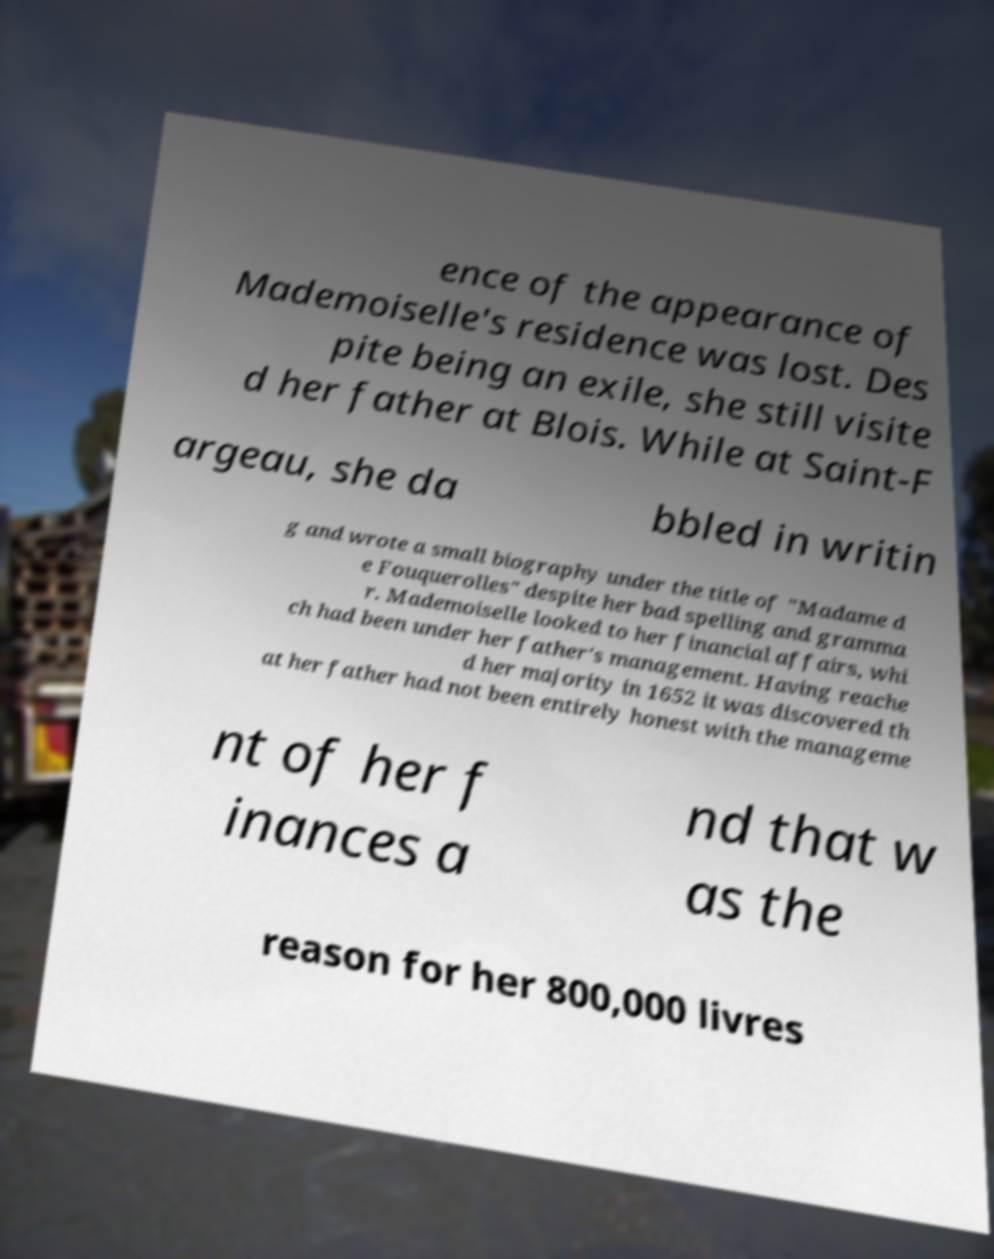Could you extract and type out the text from this image? ence of the appearance of Mademoiselle's residence was lost. Des pite being an exile, she still visite d her father at Blois. While at Saint-F argeau, she da bbled in writin g and wrote a small biography under the title of "Madame d e Fouquerolles" despite her bad spelling and gramma r. Mademoiselle looked to her financial affairs, whi ch had been under her father's management. Having reache d her majority in 1652 it was discovered th at her father had not been entirely honest with the manageme nt of her f inances a nd that w as the reason for her 800,000 livres 